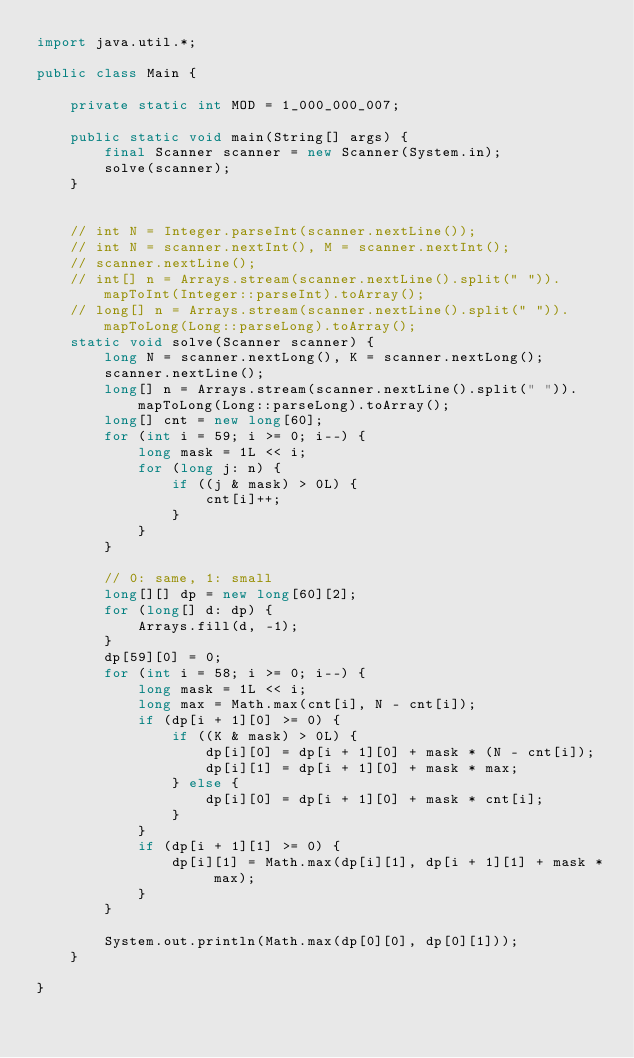Convert code to text. <code><loc_0><loc_0><loc_500><loc_500><_Java_>import java.util.*;

public class Main {

    private static int MOD = 1_000_000_007;

    public static void main(String[] args) {
        final Scanner scanner = new Scanner(System.in);
        solve(scanner);
    }


    // int N = Integer.parseInt(scanner.nextLine());
    // int N = scanner.nextInt(), M = scanner.nextInt();
    // scanner.nextLine();
    // int[] n = Arrays.stream(scanner.nextLine().split(" ")).mapToInt(Integer::parseInt).toArray();
    // long[] n = Arrays.stream(scanner.nextLine().split(" ")).mapToLong(Long::parseLong).toArray();
    static void solve(Scanner scanner) {
        long N = scanner.nextLong(), K = scanner.nextLong();
        scanner.nextLine();
        long[] n = Arrays.stream(scanner.nextLine().split(" ")).mapToLong(Long::parseLong).toArray();
        long[] cnt = new long[60];
        for (int i = 59; i >= 0; i--) {
            long mask = 1L << i;
            for (long j: n) {
                if ((j & mask) > 0L) {
                    cnt[i]++;
                }
            }
        }

        // 0: same, 1: small
        long[][] dp = new long[60][2];
        for (long[] d: dp) {
            Arrays.fill(d, -1);
        }
        dp[59][0] = 0;
        for (int i = 58; i >= 0; i--) {
            long mask = 1L << i;
            long max = Math.max(cnt[i], N - cnt[i]);
            if (dp[i + 1][0] >= 0) {
                if ((K & mask) > 0L) {
                    dp[i][0] = dp[i + 1][0] + mask * (N - cnt[i]);
                    dp[i][1] = dp[i + 1][0] + mask * max;
                } else {
                    dp[i][0] = dp[i + 1][0] + mask * cnt[i];
                }
            }
            if (dp[i + 1][1] >= 0) {
                dp[i][1] = Math.max(dp[i][1], dp[i + 1][1] + mask * max);
            }
        }

        System.out.println(Math.max(dp[0][0], dp[0][1]));
    }

}
</code> 